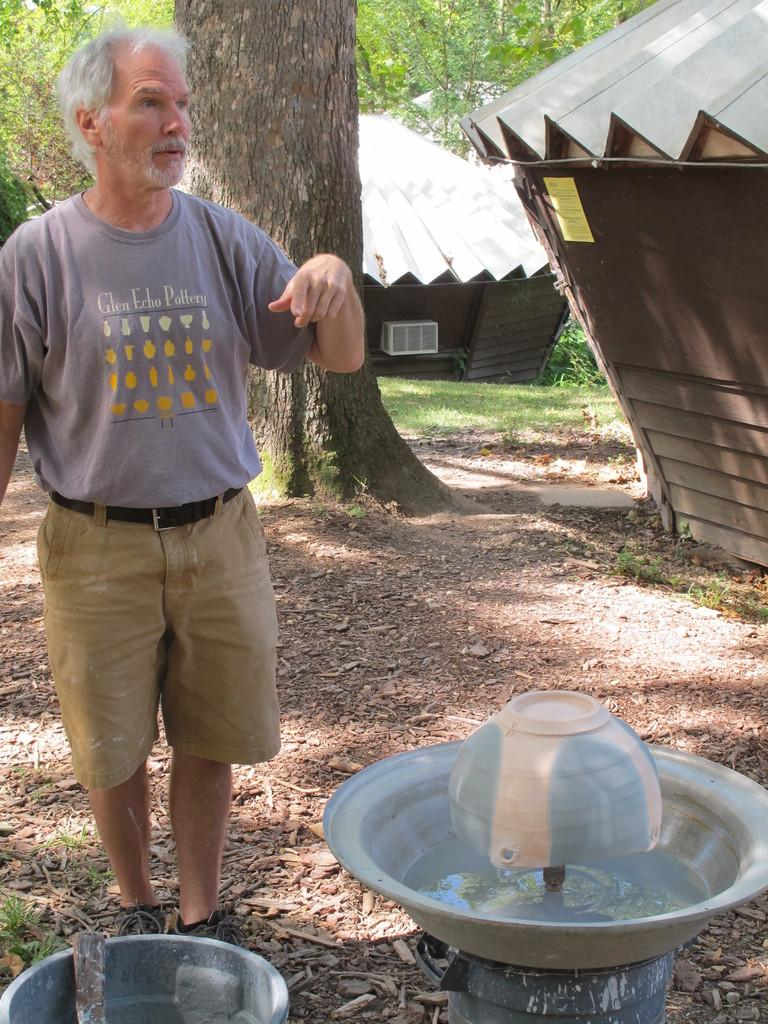<image>
Present a compact description of the photo's key features. a man with a Glen Echo shirt on 